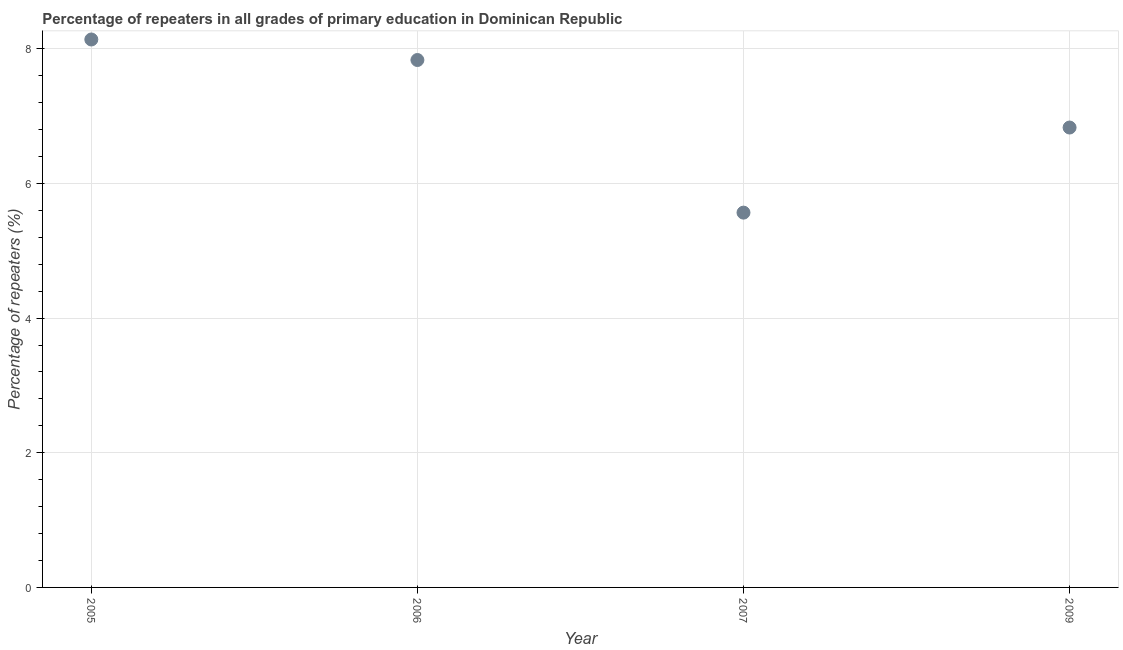What is the percentage of repeaters in primary education in 2009?
Ensure brevity in your answer.  6.83. Across all years, what is the maximum percentage of repeaters in primary education?
Offer a terse response. 8.14. Across all years, what is the minimum percentage of repeaters in primary education?
Offer a very short reply. 5.57. In which year was the percentage of repeaters in primary education maximum?
Your response must be concise. 2005. In which year was the percentage of repeaters in primary education minimum?
Give a very brief answer. 2007. What is the sum of the percentage of repeaters in primary education?
Your response must be concise. 28.36. What is the difference between the percentage of repeaters in primary education in 2005 and 2007?
Offer a terse response. 2.57. What is the average percentage of repeaters in primary education per year?
Your answer should be compact. 7.09. What is the median percentage of repeaters in primary education?
Ensure brevity in your answer.  7.33. In how many years, is the percentage of repeaters in primary education greater than 6.4 %?
Your answer should be compact. 3. What is the ratio of the percentage of repeaters in primary education in 2005 to that in 2006?
Provide a short and direct response. 1.04. What is the difference between the highest and the second highest percentage of repeaters in primary education?
Provide a succinct answer. 0.3. What is the difference between the highest and the lowest percentage of repeaters in primary education?
Provide a short and direct response. 2.57. Does the percentage of repeaters in primary education monotonically increase over the years?
Your answer should be compact. No. How many dotlines are there?
Give a very brief answer. 1. What is the difference between two consecutive major ticks on the Y-axis?
Provide a short and direct response. 2. Does the graph contain grids?
Your response must be concise. Yes. What is the title of the graph?
Ensure brevity in your answer.  Percentage of repeaters in all grades of primary education in Dominican Republic. What is the label or title of the X-axis?
Your answer should be compact. Year. What is the label or title of the Y-axis?
Offer a very short reply. Percentage of repeaters (%). What is the Percentage of repeaters (%) in 2005?
Provide a succinct answer. 8.14. What is the Percentage of repeaters (%) in 2006?
Offer a very short reply. 7.83. What is the Percentage of repeaters (%) in 2007?
Your answer should be compact. 5.57. What is the Percentage of repeaters (%) in 2009?
Offer a terse response. 6.83. What is the difference between the Percentage of repeaters (%) in 2005 and 2006?
Make the answer very short. 0.3. What is the difference between the Percentage of repeaters (%) in 2005 and 2007?
Keep it short and to the point. 2.57. What is the difference between the Percentage of repeaters (%) in 2005 and 2009?
Offer a terse response. 1.31. What is the difference between the Percentage of repeaters (%) in 2006 and 2007?
Ensure brevity in your answer.  2.27. What is the difference between the Percentage of repeaters (%) in 2006 and 2009?
Provide a succinct answer. 1. What is the difference between the Percentage of repeaters (%) in 2007 and 2009?
Provide a short and direct response. -1.26. What is the ratio of the Percentage of repeaters (%) in 2005 to that in 2006?
Provide a succinct answer. 1.04. What is the ratio of the Percentage of repeaters (%) in 2005 to that in 2007?
Provide a short and direct response. 1.46. What is the ratio of the Percentage of repeaters (%) in 2005 to that in 2009?
Your response must be concise. 1.19. What is the ratio of the Percentage of repeaters (%) in 2006 to that in 2007?
Make the answer very short. 1.41. What is the ratio of the Percentage of repeaters (%) in 2006 to that in 2009?
Give a very brief answer. 1.15. What is the ratio of the Percentage of repeaters (%) in 2007 to that in 2009?
Provide a short and direct response. 0.81. 